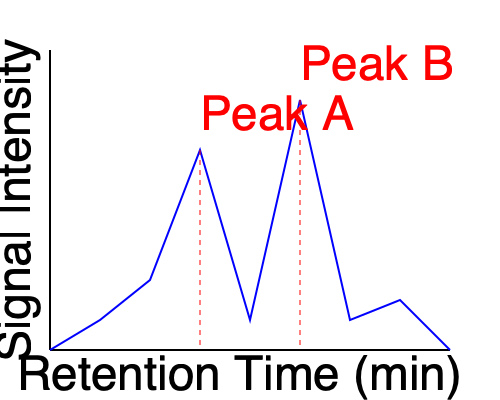Based on the chromatography graph, which pesticide residue (Peak A or Peak B) is present in higher concentration, and how does this compare to the maximum residue limit (MRL) of 0.5 mg/kg for both pesticides? To interpret the pesticide residue levels from the chromatography graph and compare them to the maximum residue limit (MRL), we need to follow these steps:

1. Identify the peaks: The graph shows two main peaks, labeled as Peak A and Peak B.

2. Compare peak heights: The height of a peak in a chromatography graph is proportional to the concentration of the compound.
   - Peak A height ≈ 200 units
   - Peak B height ≈ 250 units

3. Determine relative concentrations: Since Peak B is taller, it represents a higher concentration of pesticide residue compared to Peak A.

4. Calculate concentration ratio: 
   Ratio = Height of Peak B / Height of Peak A
   $$\frac{250}{200} = 1.25$$

5. Interpret the ratio: Peak B's concentration is approximately 1.25 times higher than Peak A's.

6. Compare to MRL: Without knowing the exact calibration of the instrument, we cannot determine the absolute concentrations. However, we can make a relative comparison:
   - If Peak A represents the MRL of 0.5 mg/kg, then Peak B would be approximately:
     $$0.5 \text{ mg/kg} \times 1.25 = 0.625 \text{ mg/kg}$$

7. Conclusion: Peak B represents a higher concentration of pesticide residue. If we assume Peak A is at the MRL, then Peak B exceeds the MRL of 0.5 mg/kg.
Answer: Peak B has a higher concentration; it likely exceeds the MRL if Peak A is at or near the limit. 